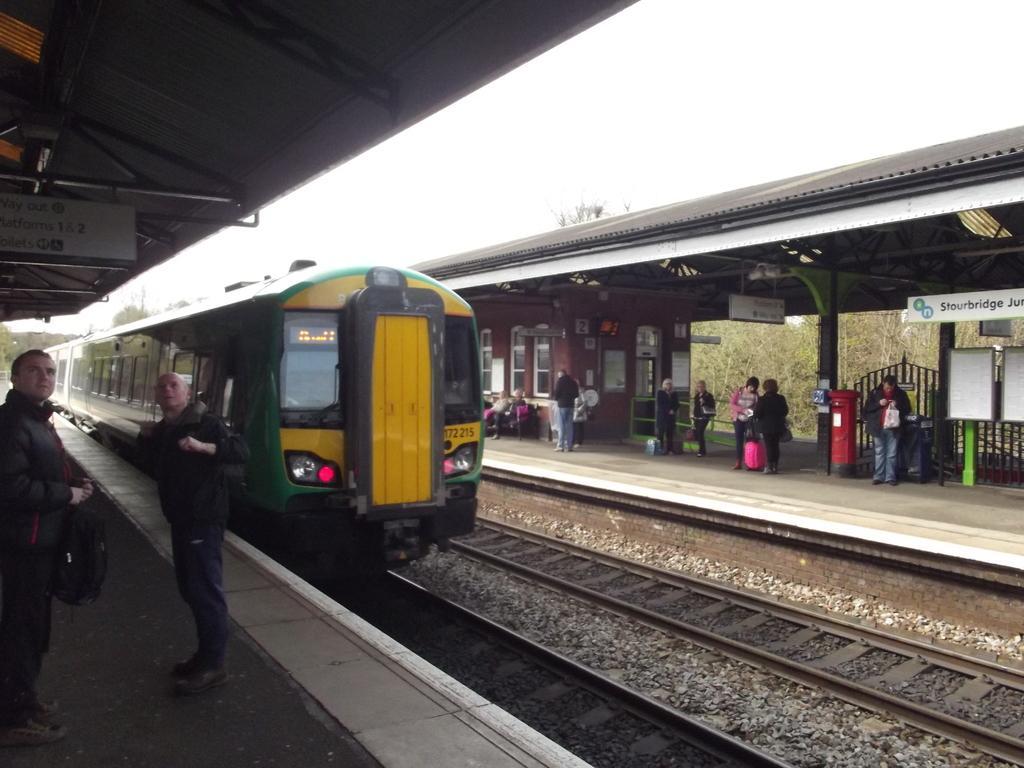Can you describe this image briefly? In this image we can see a train on the track. Beside the train we can see the platforms. On the right side, we can see the roof, room, persons with objects, fencing and a group of trees. On the left side, we can see two persons, a roof with boards and trees. At the top we can see the sky. 